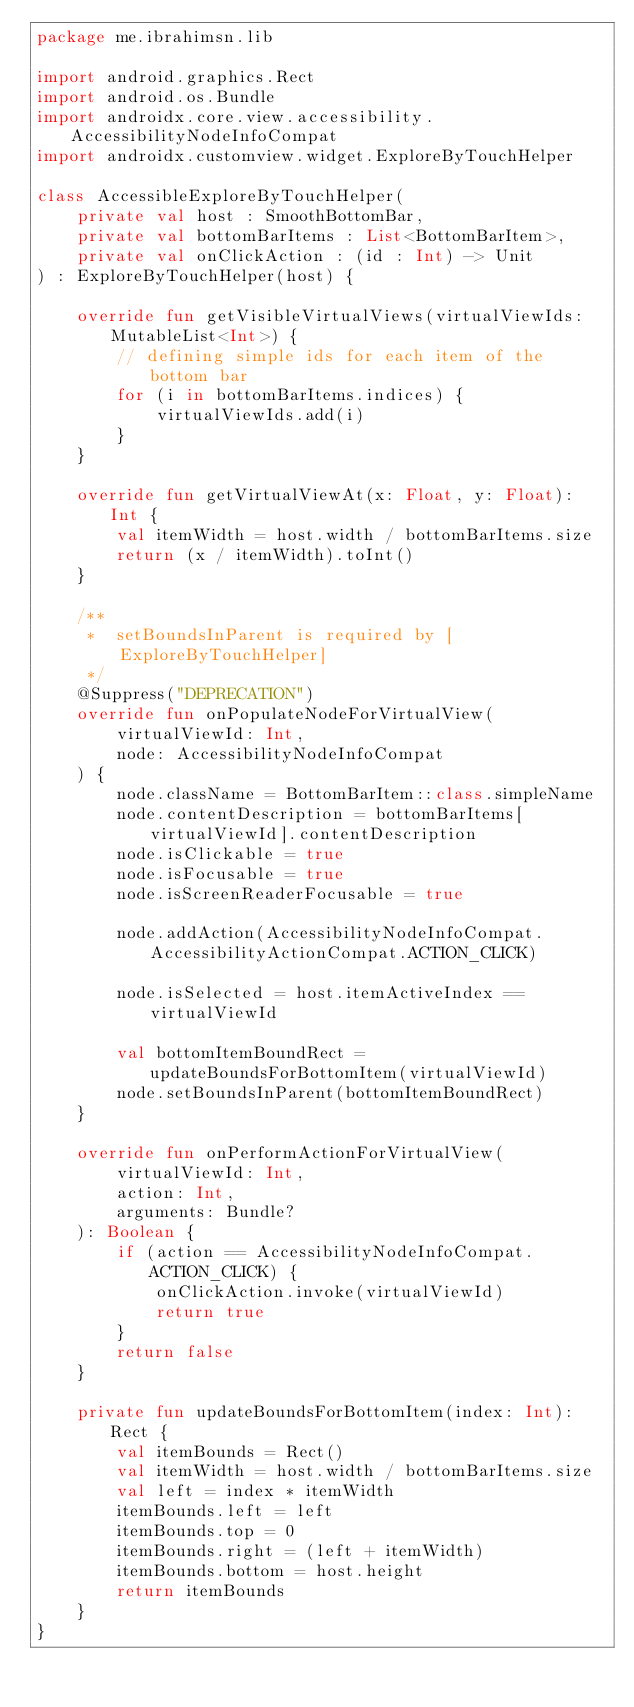Convert code to text. <code><loc_0><loc_0><loc_500><loc_500><_Kotlin_>package me.ibrahimsn.lib

import android.graphics.Rect
import android.os.Bundle
import androidx.core.view.accessibility.AccessibilityNodeInfoCompat
import androidx.customview.widget.ExploreByTouchHelper

class AccessibleExploreByTouchHelper(
    private val host : SmoothBottomBar,
    private val bottomBarItems : List<BottomBarItem>,
    private val onClickAction : (id : Int) -> Unit
) : ExploreByTouchHelper(host) {

    override fun getVisibleVirtualViews(virtualViewIds: MutableList<Int>) {
        // defining simple ids for each item of the bottom bar
        for (i in bottomBarItems.indices) {
            virtualViewIds.add(i)
        }
    }

    override fun getVirtualViewAt(x: Float, y: Float): Int {
        val itemWidth = host.width / bottomBarItems.size
        return (x / itemWidth).toInt()
    }

    /**
     *  setBoundsInParent is required by [ExploreByTouchHelper]
     */
    @Suppress("DEPRECATION")
    override fun onPopulateNodeForVirtualView(
        virtualViewId: Int,
        node: AccessibilityNodeInfoCompat
    ) {
        node.className = BottomBarItem::class.simpleName
        node.contentDescription = bottomBarItems[virtualViewId].contentDescription
        node.isClickable = true
        node.isFocusable = true
        node.isScreenReaderFocusable = true

        node.addAction(AccessibilityNodeInfoCompat.AccessibilityActionCompat.ACTION_CLICK)

        node.isSelected = host.itemActiveIndex == virtualViewId

        val bottomItemBoundRect = updateBoundsForBottomItem(virtualViewId)
        node.setBoundsInParent(bottomItemBoundRect)
    }

    override fun onPerformActionForVirtualView(
        virtualViewId: Int,
        action: Int,
        arguments: Bundle?
    ): Boolean {
        if (action == AccessibilityNodeInfoCompat.ACTION_CLICK) {
            onClickAction.invoke(virtualViewId)
            return true
        }
        return false
    }

    private fun updateBoundsForBottomItem(index: Int): Rect {
        val itemBounds = Rect()
        val itemWidth = host.width / bottomBarItems.size
        val left = index * itemWidth
        itemBounds.left = left
        itemBounds.top = 0
        itemBounds.right = (left + itemWidth)
        itemBounds.bottom = host.height
        return itemBounds
    }
}
</code> 